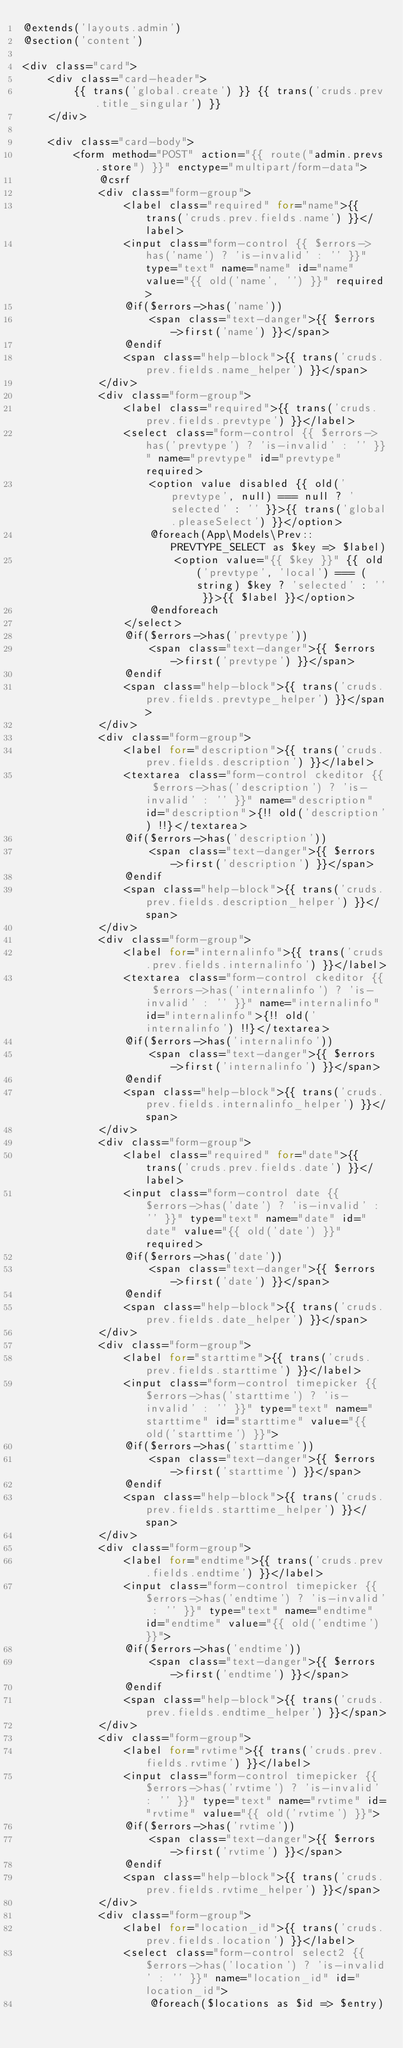Convert code to text. <code><loc_0><loc_0><loc_500><loc_500><_PHP_>@extends('layouts.admin')
@section('content')

<div class="card">
    <div class="card-header">
        {{ trans('global.create') }} {{ trans('cruds.prev.title_singular') }}
    </div>

    <div class="card-body">
        <form method="POST" action="{{ route("admin.prevs.store") }}" enctype="multipart/form-data">
            @csrf
            <div class="form-group">
                <label class="required" for="name">{{ trans('cruds.prev.fields.name') }}</label>
                <input class="form-control {{ $errors->has('name') ? 'is-invalid' : '' }}" type="text" name="name" id="name" value="{{ old('name', '') }}" required>
                @if($errors->has('name'))
                    <span class="text-danger">{{ $errors->first('name') }}</span>
                @endif
                <span class="help-block">{{ trans('cruds.prev.fields.name_helper') }}</span>
            </div>
            <div class="form-group">
                <label class="required">{{ trans('cruds.prev.fields.prevtype') }}</label>
                <select class="form-control {{ $errors->has('prevtype') ? 'is-invalid' : '' }}" name="prevtype" id="prevtype" required>
                    <option value disabled {{ old('prevtype', null) === null ? 'selected' : '' }}>{{ trans('global.pleaseSelect') }}</option>
                    @foreach(App\Models\Prev::PREVTYPE_SELECT as $key => $label)
                        <option value="{{ $key }}" {{ old('prevtype', 'local') === (string) $key ? 'selected' : '' }}>{{ $label }}</option>
                    @endforeach
                </select>
                @if($errors->has('prevtype'))
                    <span class="text-danger">{{ $errors->first('prevtype') }}</span>
                @endif
                <span class="help-block">{{ trans('cruds.prev.fields.prevtype_helper') }}</span>
            </div>
            <div class="form-group">
                <label for="description">{{ trans('cruds.prev.fields.description') }}</label>
                <textarea class="form-control ckeditor {{ $errors->has('description') ? 'is-invalid' : '' }}" name="description" id="description">{!! old('description') !!}</textarea>
                @if($errors->has('description'))
                    <span class="text-danger">{{ $errors->first('description') }}</span>
                @endif
                <span class="help-block">{{ trans('cruds.prev.fields.description_helper') }}</span>
            </div>
            <div class="form-group">
                <label for="internalinfo">{{ trans('cruds.prev.fields.internalinfo') }}</label>
                <textarea class="form-control ckeditor {{ $errors->has('internalinfo') ? 'is-invalid' : '' }}" name="internalinfo" id="internalinfo">{!! old('internalinfo') !!}</textarea>
                @if($errors->has('internalinfo'))
                    <span class="text-danger">{{ $errors->first('internalinfo') }}</span>
                @endif
                <span class="help-block">{{ trans('cruds.prev.fields.internalinfo_helper') }}</span>
            </div>
            <div class="form-group">
                <label class="required" for="date">{{ trans('cruds.prev.fields.date') }}</label>
                <input class="form-control date {{ $errors->has('date') ? 'is-invalid' : '' }}" type="text" name="date" id="date" value="{{ old('date') }}" required>
                @if($errors->has('date'))
                    <span class="text-danger">{{ $errors->first('date') }}</span>
                @endif
                <span class="help-block">{{ trans('cruds.prev.fields.date_helper') }}</span>
            </div>
            <div class="form-group">
                <label for="starttime">{{ trans('cruds.prev.fields.starttime') }}</label>
                <input class="form-control timepicker {{ $errors->has('starttime') ? 'is-invalid' : '' }}" type="text" name="starttime" id="starttime" value="{{ old('starttime') }}">
                @if($errors->has('starttime'))
                    <span class="text-danger">{{ $errors->first('starttime') }}</span>
                @endif
                <span class="help-block">{{ trans('cruds.prev.fields.starttime_helper') }}</span>
            </div>
            <div class="form-group">
                <label for="endtime">{{ trans('cruds.prev.fields.endtime') }}</label>
                <input class="form-control timepicker {{ $errors->has('endtime') ? 'is-invalid' : '' }}" type="text" name="endtime" id="endtime" value="{{ old('endtime') }}">
                @if($errors->has('endtime'))
                    <span class="text-danger">{{ $errors->first('endtime') }}</span>
                @endif
                <span class="help-block">{{ trans('cruds.prev.fields.endtime_helper') }}</span>
            </div>
            <div class="form-group">
                <label for="rvtime">{{ trans('cruds.prev.fields.rvtime') }}</label>
                <input class="form-control timepicker {{ $errors->has('rvtime') ? 'is-invalid' : '' }}" type="text" name="rvtime" id="rvtime" value="{{ old('rvtime') }}">
                @if($errors->has('rvtime'))
                    <span class="text-danger">{{ $errors->first('rvtime') }}</span>
                @endif
                <span class="help-block">{{ trans('cruds.prev.fields.rvtime_helper') }}</span>
            </div>
            <div class="form-group">
                <label for="location_id">{{ trans('cruds.prev.fields.location') }}</label>
                <select class="form-control select2 {{ $errors->has('location') ? 'is-invalid' : '' }}" name="location_id" id="location_id">
                    @foreach($locations as $id => $entry)</code> 